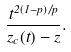Convert formula to latex. <formula><loc_0><loc_0><loc_500><loc_500>\frac { t ^ { 2 ( 1 - p ) / p } } { z _ { c } ( t ) - z } .</formula> 